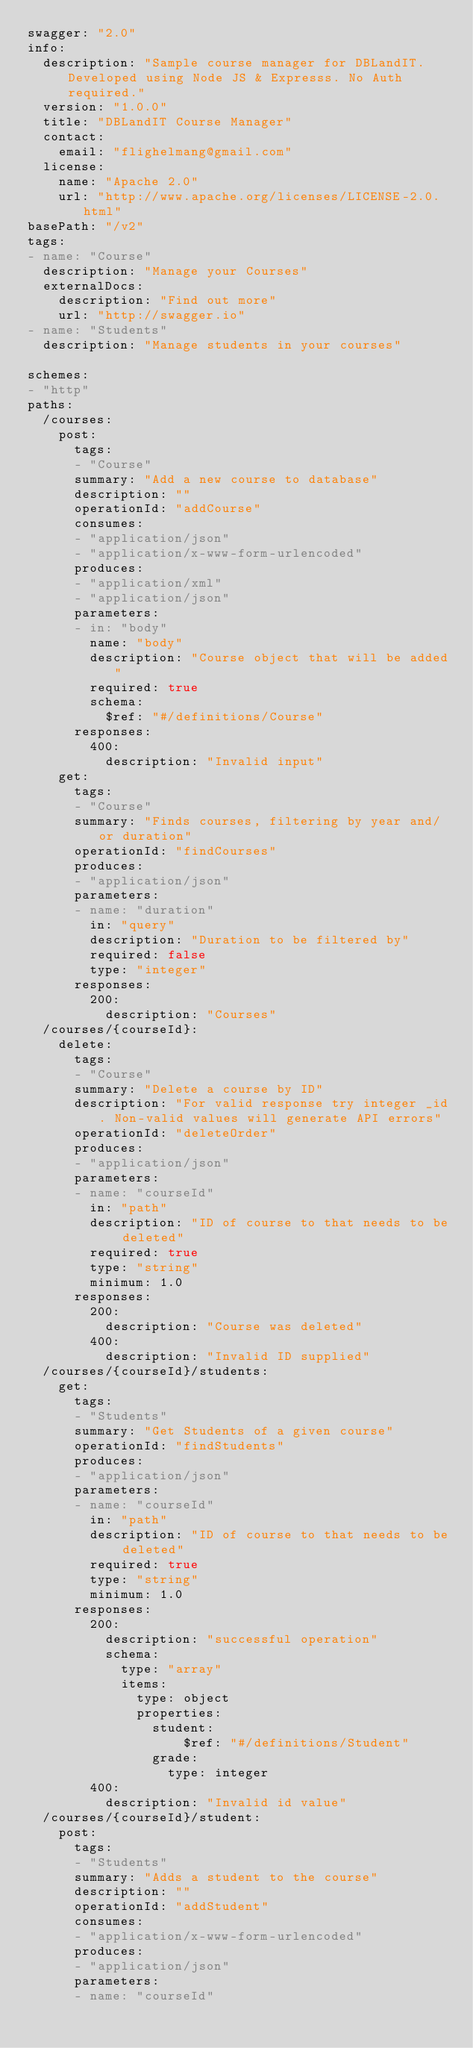<code> <loc_0><loc_0><loc_500><loc_500><_YAML_>swagger: "2.0"
info:
  description: "Sample course manager for DBLandIT.  Developed using Node JS & Expresss. No Auth required."
  version: "1.0.0"
  title: "DBLandIT Course Manager"
  contact:
    email: "flighelmang@gmail.com"
  license:
    name: "Apache 2.0"
    url: "http://www.apache.org/licenses/LICENSE-2.0.html"
basePath: "/v2"
tags:
- name: "Course"
  description: "Manage your Courses"
  externalDocs:
    description: "Find out more"
    url: "http://swagger.io"
- name: "Students"
  description: "Manage students in your courses"

schemes:
- "http"
paths:
  /courses:
    post:
      tags:
      - "Course"
      summary: "Add a new course to database"
      description: ""
      operationId: "addCourse"
      consumes:
      - "application/json"
      - "application/x-www-form-urlencoded"
      produces:
      - "application/xml"
      - "application/json"
      parameters:
      - in: "body"
        name: "body"
        description: "Course object that will be added"
        required: true
        schema:
          $ref: "#/definitions/Course"
      responses:
        400:
          description: "Invalid input"
    get:
      tags:
      - "Course"
      summary: "Finds courses, filtering by year and/or duration"
      operationId: "findCourses"
      produces:
      - "application/json"
      parameters:
      - name: "duration"
        in: "query"
        description: "Duration to be filtered by"
        required: false
        type: "integer"
      responses:
        200:
          description: "Courses"
  /courses/{courseId}:
    delete:
      tags:
      - "Course"
      summary: "Delete a course by ID"
      description: "For valid response try integer _id. Non-valid values will generate API errors"
      operationId: "deleteOrder"
      produces:
      - "application/json"
      parameters:
      - name: "courseId"
        in: "path"
        description: "ID of course to that needs to be deleted"
        required: true
        type: "string"
        minimum: 1.0
      responses:
        200:
          description: "Course was deleted"
        400:
          description: "Invalid ID supplied"
  /courses/{courseId}/students:
    get:
      tags:
      - "Students"
      summary: "Get Students of a given course"
      operationId: "findStudents"
      produces:
      - "application/json"
      parameters:
      - name: "courseId"
        in: "path"
        description: "ID of course to that needs to be deleted"
        required: true
        type: "string"
        minimum: 1.0
      responses:
        200:
          description: "successful operation"
          schema:
            type: "array"
            items:
              type: object
              properties:
                student: 
                    $ref: "#/definitions/Student"
                grade: 
                  type: integer
        400:
          description: "Invalid id value"
  /courses/{courseId}/student:
    post:
      tags:
      - "Students"
      summary: "Adds a student to the course"
      description: ""
      operationId: "addStudent"
      consumes:
      - "application/x-www-form-urlencoded"
      produces:
      - "application/json"
      parameters:
      - name: "courseId"</code> 